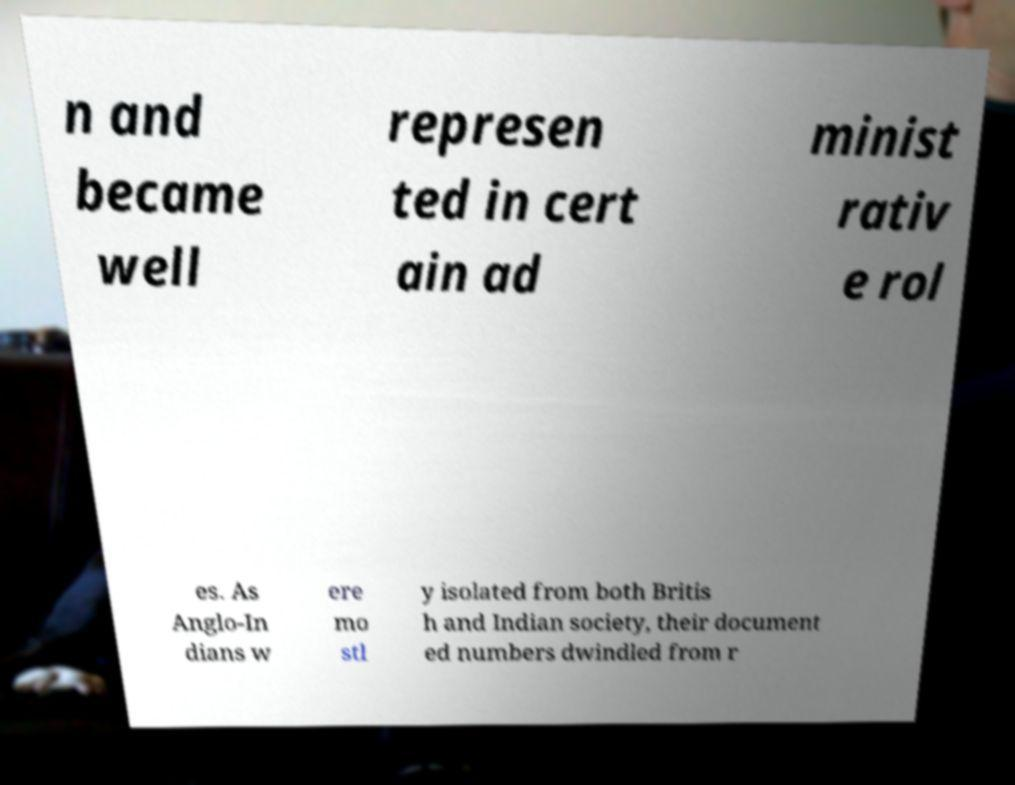Can you accurately transcribe the text from the provided image for me? n and became well represen ted in cert ain ad minist rativ e rol es. As Anglo-In dians w ere mo stl y isolated from both Britis h and Indian society, their document ed numbers dwindled from r 